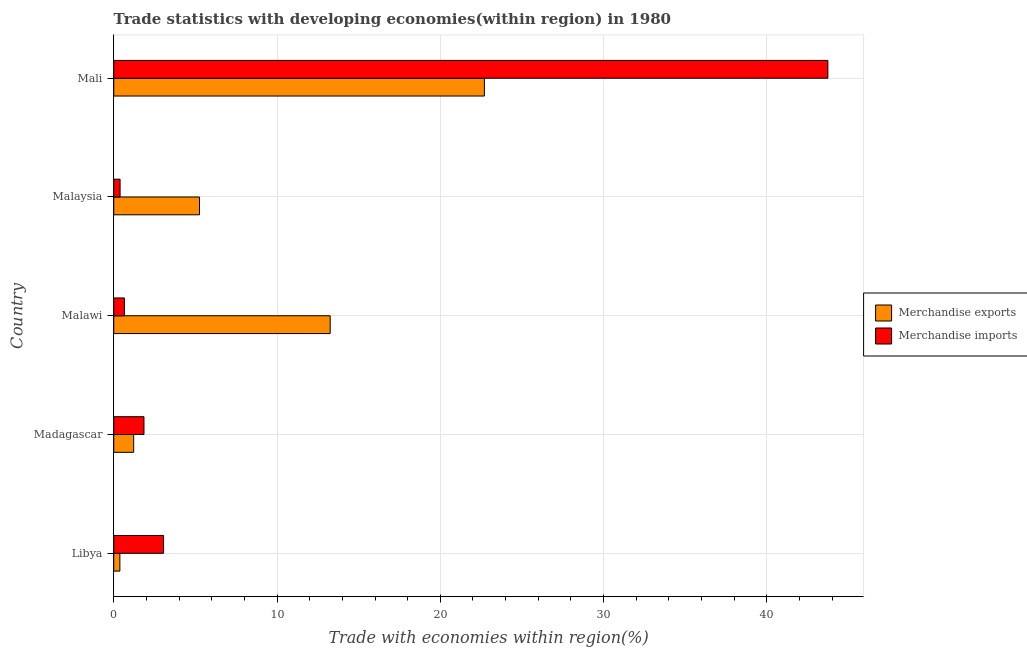Are the number of bars per tick equal to the number of legend labels?
Provide a short and direct response. Yes. Are the number of bars on each tick of the Y-axis equal?
Provide a short and direct response. Yes. What is the label of the 5th group of bars from the top?
Make the answer very short. Libya. In how many cases, is the number of bars for a given country not equal to the number of legend labels?
Ensure brevity in your answer.  0. What is the merchandise imports in Madagascar?
Ensure brevity in your answer.  1.85. Across all countries, what is the maximum merchandise imports?
Your answer should be compact. 43.74. Across all countries, what is the minimum merchandise exports?
Provide a short and direct response. 0.38. In which country was the merchandise exports maximum?
Your answer should be compact. Mali. In which country was the merchandise imports minimum?
Your answer should be very brief. Malaysia. What is the total merchandise exports in the graph?
Offer a very short reply. 42.8. What is the difference between the merchandise imports in Madagascar and that in Malaysia?
Make the answer very short. 1.46. What is the difference between the merchandise exports in Mali and the merchandise imports in Madagascar?
Ensure brevity in your answer.  20.85. What is the average merchandise imports per country?
Offer a very short reply. 9.94. What is the difference between the merchandise imports and merchandise exports in Malawi?
Your response must be concise. -12.6. What is the ratio of the merchandise exports in Malawi to that in Mali?
Ensure brevity in your answer.  0.58. Is the difference between the merchandise imports in Libya and Malaysia greater than the difference between the merchandise exports in Libya and Malaysia?
Give a very brief answer. Yes. What is the difference between the highest and the second highest merchandise imports?
Ensure brevity in your answer.  40.69. What is the difference between the highest and the lowest merchandise exports?
Keep it short and to the point. 22.32. In how many countries, is the merchandise imports greater than the average merchandise imports taken over all countries?
Ensure brevity in your answer.  1. Is the sum of the merchandise exports in Madagascar and Malaysia greater than the maximum merchandise imports across all countries?
Provide a short and direct response. No. What does the 1st bar from the top in Libya represents?
Your answer should be very brief. Merchandise imports. What does the 2nd bar from the bottom in Madagascar represents?
Offer a terse response. Merchandise imports. Are all the bars in the graph horizontal?
Ensure brevity in your answer.  Yes. Does the graph contain any zero values?
Offer a very short reply. No. What is the title of the graph?
Provide a succinct answer. Trade statistics with developing economies(within region) in 1980. What is the label or title of the X-axis?
Your answer should be very brief. Trade with economies within region(%). What is the Trade with economies within region(%) of Merchandise exports in Libya?
Provide a succinct answer. 0.38. What is the Trade with economies within region(%) of Merchandise imports in Libya?
Give a very brief answer. 3.05. What is the Trade with economies within region(%) of Merchandise exports in Madagascar?
Your answer should be compact. 1.22. What is the Trade with economies within region(%) of Merchandise imports in Madagascar?
Keep it short and to the point. 1.85. What is the Trade with economies within region(%) in Merchandise exports in Malawi?
Provide a succinct answer. 13.26. What is the Trade with economies within region(%) of Merchandise imports in Malawi?
Make the answer very short. 0.65. What is the Trade with economies within region(%) in Merchandise exports in Malaysia?
Offer a very short reply. 5.25. What is the Trade with economies within region(%) of Merchandise imports in Malaysia?
Offer a very short reply. 0.39. What is the Trade with economies within region(%) in Merchandise exports in Mali?
Give a very brief answer. 22.7. What is the Trade with economies within region(%) of Merchandise imports in Mali?
Make the answer very short. 43.74. Across all countries, what is the maximum Trade with economies within region(%) of Merchandise exports?
Give a very brief answer. 22.7. Across all countries, what is the maximum Trade with economies within region(%) in Merchandise imports?
Give a very brief answer. 43.74. Across all countries, what is the minimum Trade with economies within region(%) of Merchandise exports?
Ensure brevity in your answer.  0.38. Across all countries, what is the minimum Trade with economies within region(%) in Merchandise imports?
Your answer should be very brief. 0.39. What is the total Trade with economies within region(%) of Merchandise exports in the graph?
Keep it short and to the point. 42.8. What is the total Trade with economies within region(%) of Merchandise imports in the graph?
Provide a succinct answer. 49.68. What is the difference between the Trade with economies within region(%) of Merchandise exports in Libya and that in Madagascar?
Give a very brief answer. -0.85. What is the difference between the Trade with economies within region(%) of Merchandise imports in Libya and that in Madagascar?
Ensure brevity in your answer.  1.2. What is the difference between the Trade with economies within region(%) in Merchandise exports in Libya and that in Malawi?
Provide a short and direct response. -12.88. What is the difference between the Trade with economies within region(%) of Merchandise imports in Libya and that in Malawi?
Ensure brevity in your answer.  2.4. What is the difference between the Trade with economies within region(%) in Merchandise exports in Libya and that in Malaysia?
Provide a short and direct response. -4.88. What is the difference between the Trade with economies within region(%) in Merchandise imports in Libya and that in Malaysia?
Provide a succinct answer. 2.66. What is the difference between the Trade with economies within region(%) in Merchandise exports in Libya and that in Mali?
Offer a terse response. -22.32. What is the difference between the Trade with economies within region(%) of Merchandise imports in Libya and that in Mali?
Offer a very short reply. -40.69. What is the difference between the Trade with economies within region(%) of Merchandise exports in Madagascar and that in Malawi?
Ensure brevity in your answer.  -12.03. What is the difference between the Trade with economies within region(%) of Merchandise imports in Madagascar and that in Malawi?
Your answer should be compact. 1.2. What is the difference between the Trade with economies within region(%) of Merchandise exports in Madagascar and that in Malaysia?
Make the answer very short. -4.03. What is the difference between the Trade with economies within region(%) in Merchandise imports in Madagascar and that in Malaysia?
Ensure brevity in your answer.  1.46. What is the difference between the Trade with economies within region(%) in Merchandise exports in Madagascar and that in Mali?
Make the answer very short. -21.48. What is the difference between the Trade with economies within region(%) in Merchandise imports in Madagascar and that in Mali?
Make the answer very short. -41.88. What is the difference between the Trade with economies within region(%) in Merchandise exports in Malawi and that in Malaysia?
Offer a very short reply. 8. What is the difference between the Trade with economies within region(%) in Merchandise imports in Malawi and that in Malaysia?
Offer a very short reply. 0.27. What is the difference between the Trade with economies within region(%) in Merchandise exports in Malawi and that in Mali?
Ensure brevity in your answer.  -9.44. What is the difference between the Trade with economies within region(%) of Merchandise imports in Malawi and that in Mali?
Your answer should be very brief. -43.08. What is the difference between the Trade with economies within region(%) in Merchandise exports in Malaysia and that in Mali?
Provide a succinct answer. -17.45. What is the difference between the Trade with economies within region(%) of Merchandise imports in Malaysia and that in Mali?
Give a very brief answer. -43.35. What is the difference between the Trade with economies within region(%) in Merchandise exports in Libya and the Trade with economies within region(%) in Merchandise imports in Madagascar?
Your response must be concise. -1.48. What is the difference between the Trade with economies within region(%) of Merchandise exports in Libya and the Trade with economies within region(%) of Merchandise imports in Malawi?
Offer a very short reply. -0.28. What is the difference between the Trade with economies within region(%) in Merchandise exports in Libya and the Trade with economies within region(%) in Merchandise imports in Malaysia?
Give a very brief answer. -0.01. What is the difference between the Trade with economies within region(%) of Merchandise exports in Libya and the Trade with economies within region(%) of Merchandise imports in Mali?
Give a very brief answer. -43.36. What is the difference between the Trade with economies within region(%) of Merchandise exports in Madagascar and the Trade with economies within region(%) of Merchandise imports in Malawi?
Keep it short and to the point. 0.57. What is the difference between the Trade with economies within region(%) in Merchandise exports in Madagascar and the Trade with economies within region(%) in Merchandise imports in Malaysia?
Your answer should be compact. 0.83. What is the difference between the Trade with economies within region(%) in Merchandise exports in Madagascar and the Trade with economies within region(%) in Merchandise imports in Mali?
Provide a succinct answer. -42.51. What is the difference between the Trade with economies within region(%) in Merchandise exports in Malawi and the Trade with economies within region(%) in Merchandise imports in Malaysia?
Your answer should be very brief. 12.87. What is the difference between the Trade with economies within region(%) of Merchandise exports in Malawi and the Trade with economies within region(%) of Merchandise imports in Mali?
Your answer should be compact. -30.48. What is the difference between the Trade with economies within region(%) in Merchandise exports in Malaysia and the Trade with economies within region(%) in Merchandise imports in Mali?
Your answer should be compact. -38.48. What is the average Trade with economies within region(%) of Merchandise exports per country?
Provide a short and direct response. 8.56. What is the average Trade with economies within region(%) of Merchandise imports per country?
Your answer should be compact. 9.94. What is the difference between the Trade with economies within region(%) of Merchandise exports and Trade with economies within region(%) of Merchandise imports in Libya?
Your answer should be very brief. -2.67. What is the difference between the Trade with economies within region(%) of Merchandise exports and Trade with economies within region(%) of Merchandise imports in Madagascar?
Offer a terse response. -0.63. What is the difference between the Trade with economies within region(%) in Merchandise exports and Trade with economies within region(%) in Merchandise imports in Malawi?
Make the answer very short. 12.6. What is the difference between the Trade with economies within region(%) of Merchandise exports and Trade with economies within region(%) of Merchandise imports in Malaysia?
Give a very brief answer. 4.86. What is the difference between the Trade with economies within region(%) of Merchandise exports and Trade with economies within region(%) of Merchandise imports in Mali?
Keep it short and to the point. -21.04. What is the ratio of the Trade with economies within region(%) of Merchandise exports in Libya to that in Madagascar?
Provide a succinct answer. 0.31. What is the ratio of the Trade with economies within region(%) in Merchandise imports in Libya to that in Madagascar?
Your answer should be compact. 1.65. What is the ratio of the Trade with economies within region(%) of Merchandise exports in Libya to that in Malawi?
Offer a very short reply. 0.03. What is the ratio of the Trade with economies within region(%) of Merchandise imports in Libya to that in Malawi?
Give a very brief answer. 4.66. What is the ratio of the Trade with economies within region(%) of Merchandise exports in Libya to that in Malaysia?
Provide a succinct answer. 0.07. What is the ratio of the Trade with economies within region(%) of Merchandise imports in Libya to that in Malaysia?
Your answer should be compact. 7.87. What is the ratio of the Trade with economies within region(%) of Merchandise exports in Libya to that in Mali?
Offer a terse response. 0.02. What is the ratio of the Trade with economies within region(%) in Merchandise imports in Libya to that in Mali?
Your answer should be compact. 0.07. What is the ratio of the Trade with economies within region(%) in Merchandise exports in Madagascar to that in Malawi?
Your answer should be very brief. 0.09. What is the ratio of the Trade with economies within region(%) of Merchandise imports in Madagascar to that in Malawi?
Ensure brevity in your answer.  2.83. What is the ratio of the Trade with economies within region(%) in Merchandise exports in Madagascar to that in Malaysia?
Your answer should be very brief. 0.23. What is the ratio of the Trade with economies within region(%) in Merchandise imports in Madagascar to that in Malaysia?
Provide a short and direct response. 4.78. What is the ratio of the Trade with economies within region(%) of Merchandise exports in Madagascar to that in Mali?
Provide a short and direct response. 0.05. What is the ratio of the Trade with economies within region(%) of Merchandise imports in Madagascar to that in Mali?
Offer a very short reply. 0.04. What is the ratio of the Trade with economies within region(%) of Merchandise exports in Malawi to that in Malaysia?
Your response must be concise. 2.52. What is the ratio of the Trade with economies within region(%) of Merchandise imports in Malawi to that in Malaysia?
Give a very brief answer. 1.69. What is the ratio of the Trade with economies within region(%) in Merchandise exports in Malawi to that in Mali?
Provide a succinct answer. 0.58. What is the ratio of the Trade with economies within region(%) of Merchandise imports in Malawi to that in Mali?
Your answer should be compact. 0.01. What is the ratio of the Trade with economies within region(%) of Merchandise exports in Malaysia to that in Mali?
Your answer should be very brief. 0.23. What is the ratio of the Trade with economies within region(%) in Merchandise imports in Malaysia to that in Mali?
Your answer should be compact. 0.01. What is the difference between the highest and the second highest Trade with economies within region(%) of Merchandise exports?
Keep it short and to the point. 9.44. What is the difference between the highest and the second highest Trade with economies within region(%) in Merchandise imports?
Your answer should be compact. 40.69. What is the difference between the highest and the lowest Trade with economies within region(%) in Merchandise exports?
Provide a short and direct response. 22.32. What is the difference between the highest and the lowest Trade with economies within region(%) in Merchandise imports?
Provide a succinct answer. 43.35. 